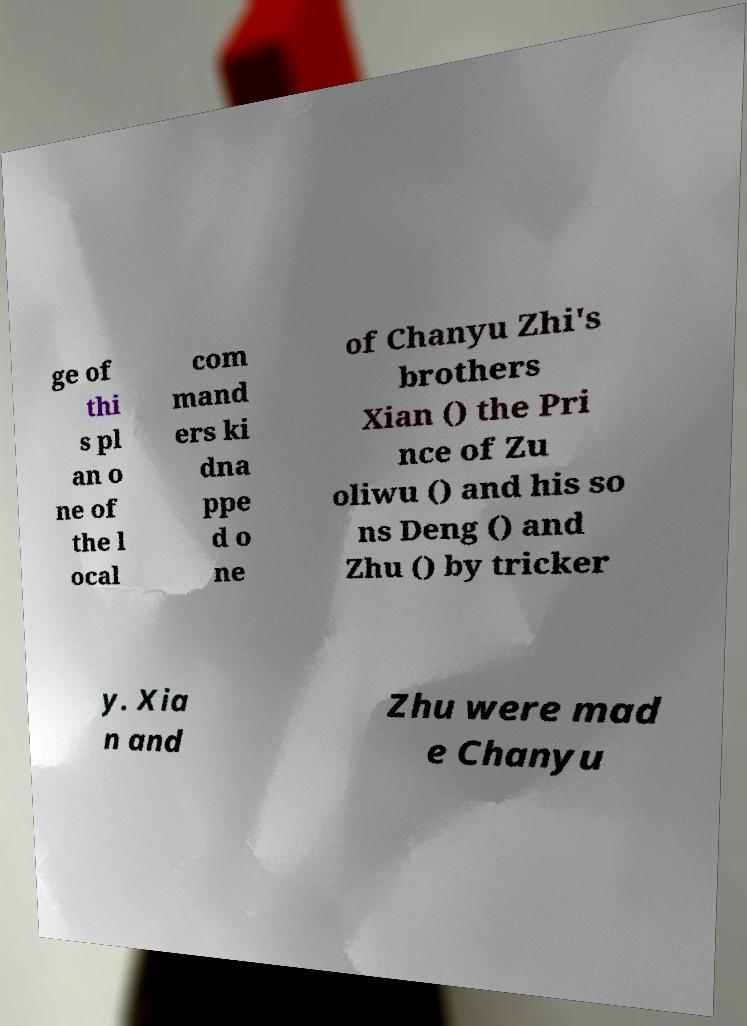For documentation purposes, I need the text within this image transcribed. Could you provide that? ge of thi s pl an o ne of the l ocal com mand ers ki dna ppe d o ne of Chanyu Zhi's brothers Xian () the Pri nce of Zu oliwu () and his so ns Deng () and Zhu () by tricker y. Xia n and Zhu were mad e Chanyu 